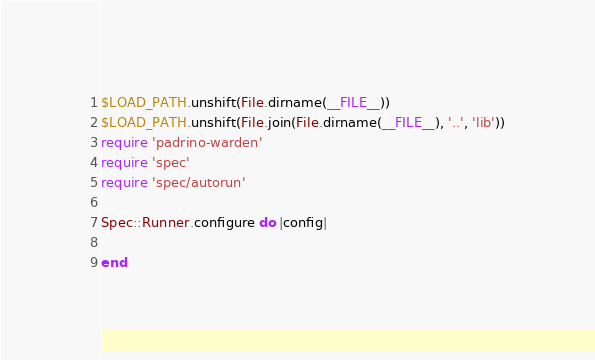Convert code to text. <code><loc_0><loc_0><loc_500><loc_500><_Ruby_>$LOAD_PATH.unshift(File.dirname(__FILE__))
$LOAD_PATH.unshift(File.join(File.dirname(__FILE__), '..', 'lib'))
require 'padrino-warden'
require 'spec'
require 'spec/autorun'

Spec::Runner.configure do |config|
  
end
</code> 